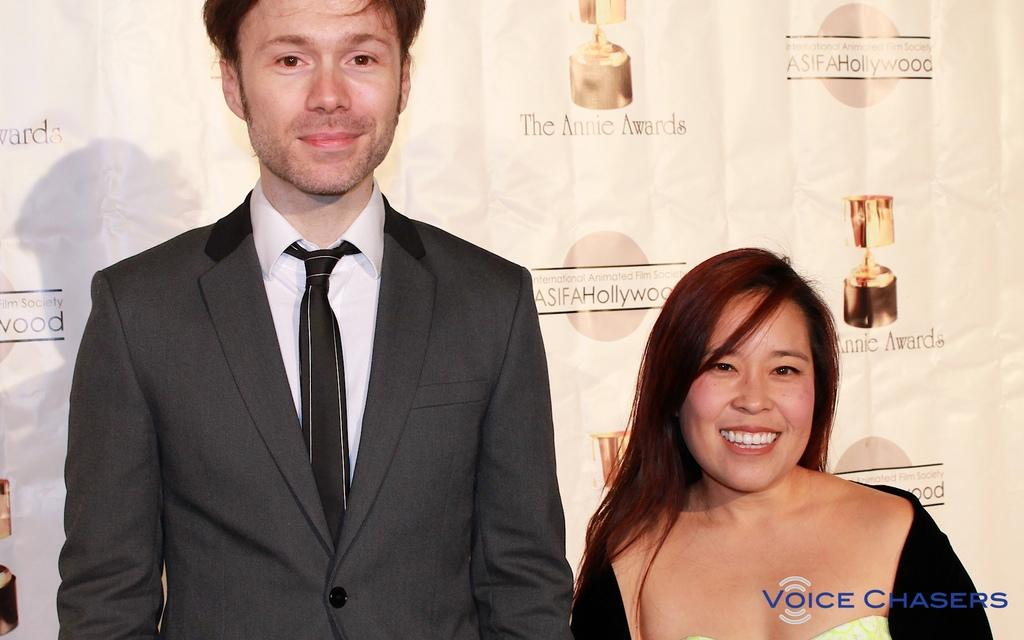How many people are present in the image? There are two people standing in the image. What is the surface on which the people are standing? The people are standing on the floor. What can be seen in the background of the image? There is a banner visible in the background of the image. What type of fiction is the book the people are reading in the image? There is no book present in the image; the people are simply standing on the floor with a banner visible in the background, of the image? 